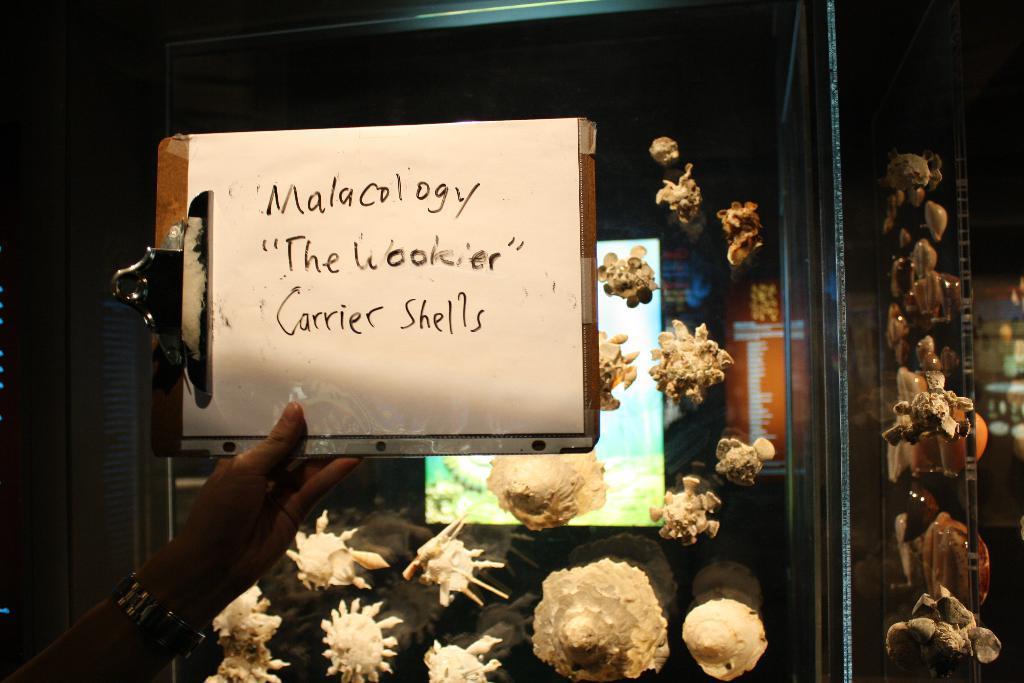Describe this image in one or two sentences. In this image we can see a person's hand holding a clipboard with paper. Behind the clipboard there is a glass object with shells. In the background of the image there are boards and other objects. On the right side of the image there are shells and glass object. 